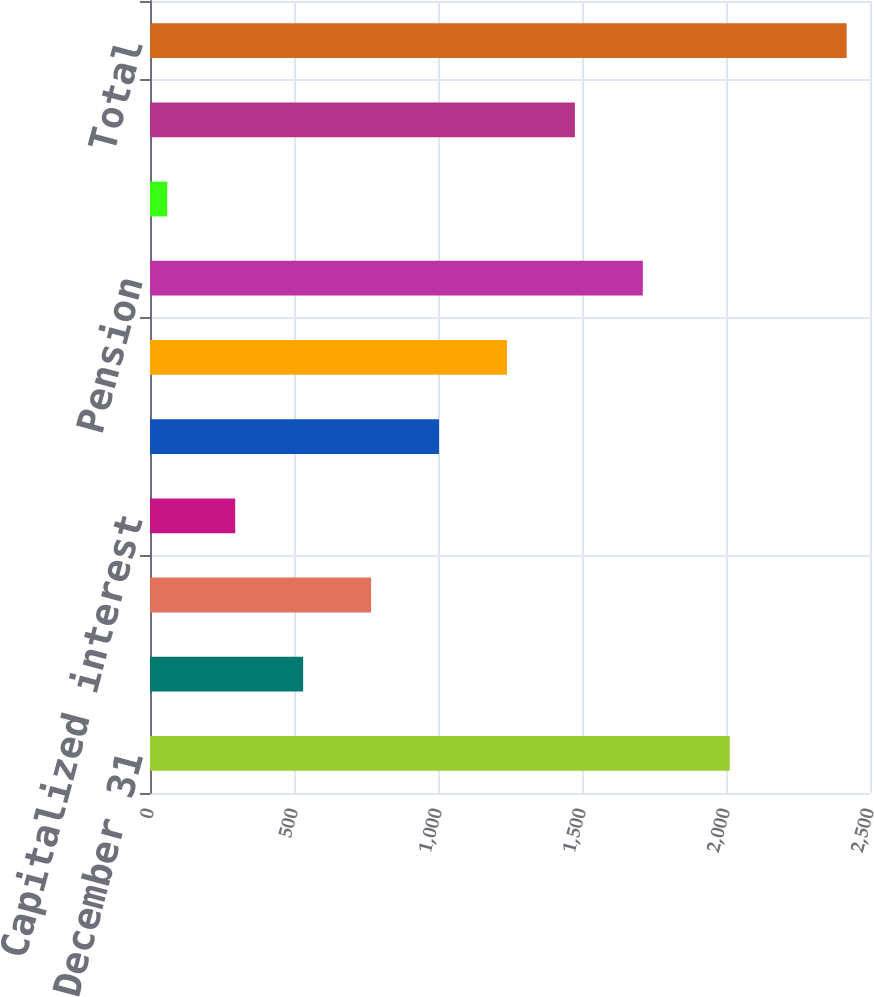<chart> <loc_0><loc_0><loc_500><loc_500><bar_chart><fcel>Years ended December 31<fcel>Share-based plans<fcel>Deferred compensation<fcel>Capitalized interest<fcel>Eliminations and other<fcel>Sub-total<fcel>Pension<fcel>Postretirement<fcel>Pension and Postretirement<fcel>Total<nl><fcel>2013<fcel>531.8<fcel>767.7<fcel>295.9<fcel>1003.6<fcel>1239.5<fcel>1711.3<fcel>60<fcel>1475.4<fcel>2419<nl></chart> 